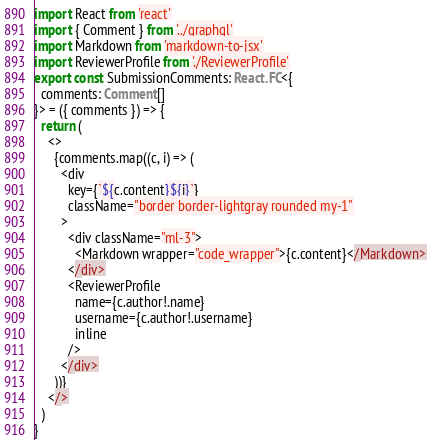Convert code to text. <code><loc_0><loc_0><loc_500><loc_500><_TypeScript_>import React from 'react'
import { Comment } from '../graphql'
import Markdown from 'markdown-to-jsx'
import ReviewerProfile from './ReviewerProfile'
export const SubmissionComments: React.FC<{
  comments: Comment[]
}> = ({ comments }) => {
  return (
    <>
      {comments.map((c, i) => (
        <div
          key={`${c.content}${i}`}
          className="border border-lightgray rounded my-1"
        >
          <div className="ml-3">
            <Markdown wrapper="code_wrapper">{c.content}</Markdown>
          </div>
          <ReviewerProfile
            name={c.author!.name}
            username={c.author!.username}
            inline
          />
        </div>
      ))}
    </>
  )
}
</code> 